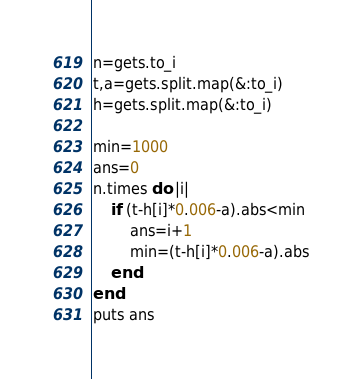Convert code to text. <code><loc_0><loc_0><loc_500><loc_500><_Ruby_>n=gets.to_i
t,a=gets.split.map(&:to_i)
h=gets.split.map(&:to_i)

min=1000
ans=0
n.times do |i|
    if (t-h[i]*0.006-a).abs<min
        ans=i+1
        min=(t-h[i]*0.006-a).abs
    end
end
puts ans
</code> 